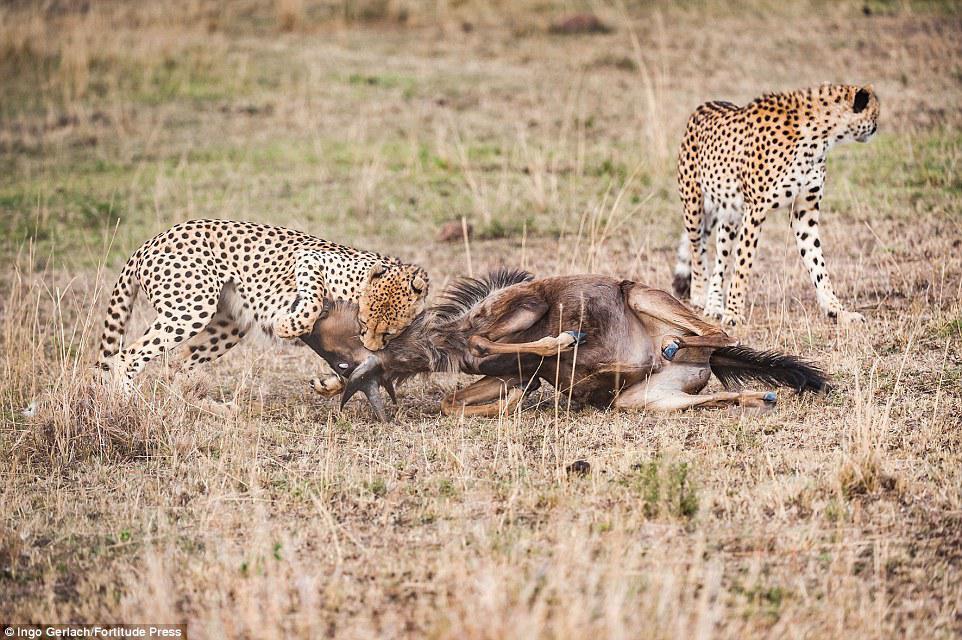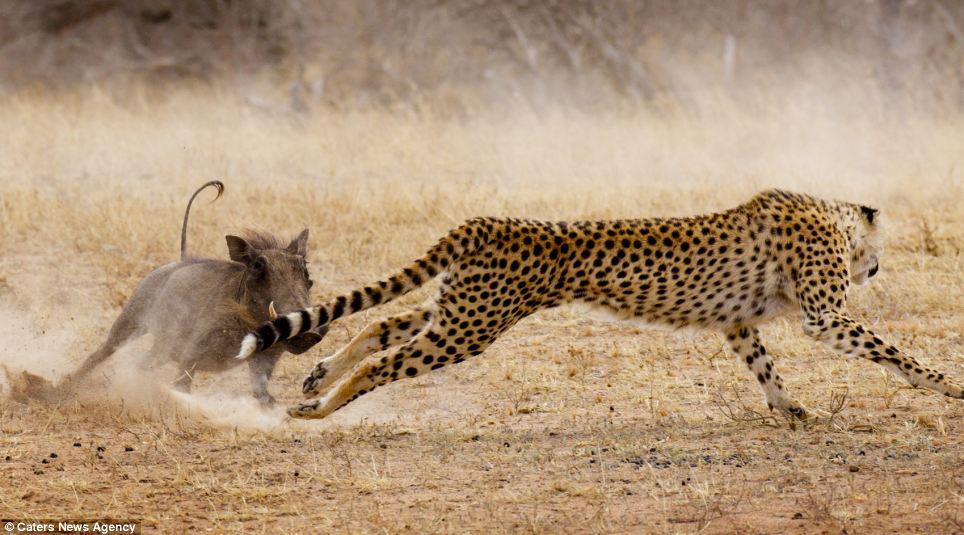The first image is the image on the left, the second image is the image on the right. For the images shown, is this caption "One of the big cats is running very fast and the others are eating." true? Answer yes or no. Yes. The first image is the image on the left, the second image is the image on the right. Given the left and right images, does the statement "There is at least one cheetah in motion." hold true? Answer yes or no. Yes. 